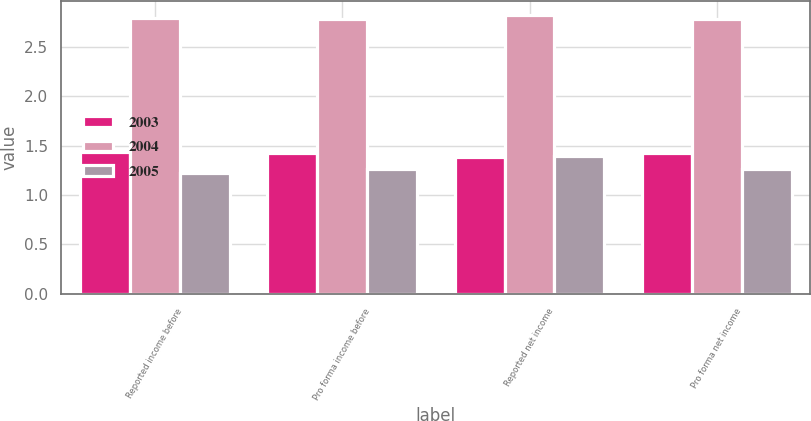Convert chart. <chart><loc_0><loc_0><loc_500><loc_500><stacked_bar_chart><ecel><fcel>Reported income before<fcel>Pro forma income before<fcel>Reported net income<fcel>Pro forma net income<nl><fcel>2003<fcel>1.44<fcel>1.43<fcel>1.38<fcel>1.43<nl><fcel>2004<fcel>2.79<fcel>2.78<fcel>2.82<fcel>2.78<nl><fcel>2005<fcel>1.22<fcel>1.26<fcel>1.39<fcel>1.26<nl></chart> 